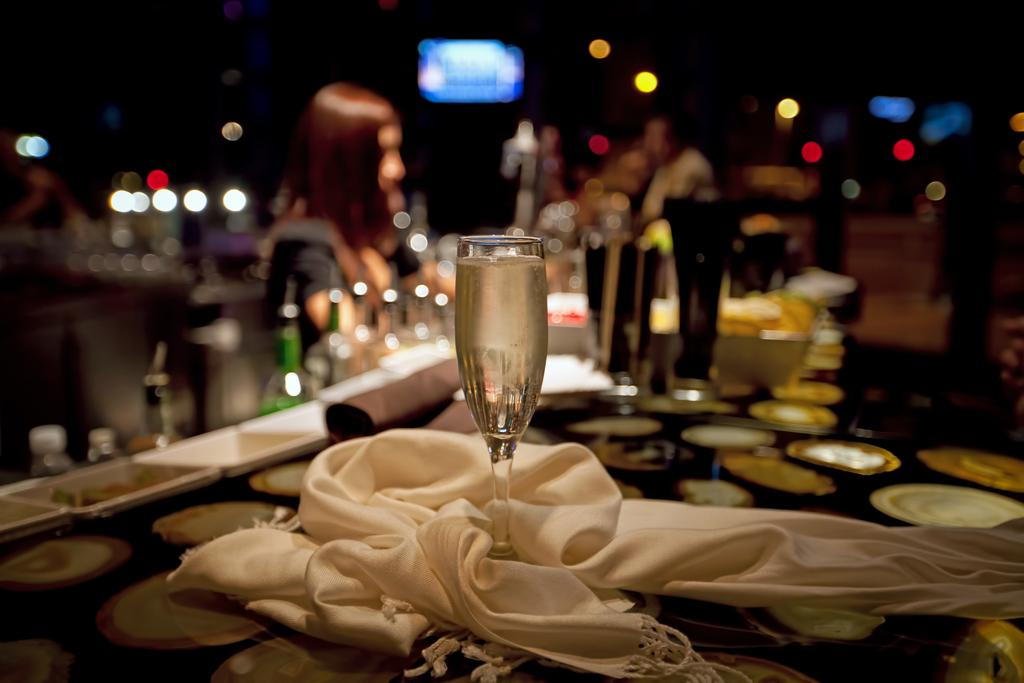What is inside the glass that is visible in the image? There is a drink in the glass that is visible in the image. Where is the glass located in the image? The glass is placed on a table in the image. What is covering the glass in the image? There is a white cloth around the glass in the image. How is the background of the glass depicted in the image? The background of the glass is blurry in the image. What is the governor doing with their mouth in the image? There is no governor or mouth present in the image. 